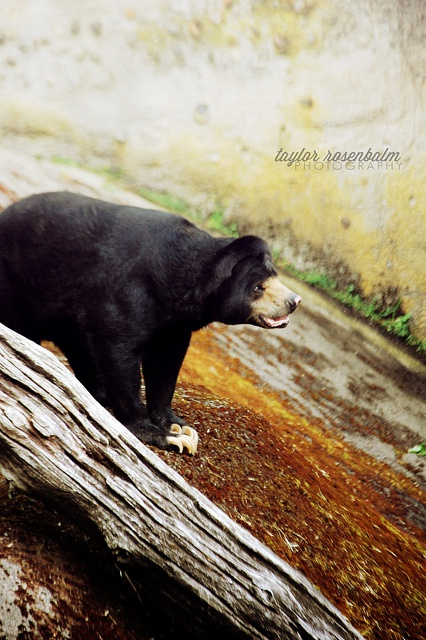Describe the objects in this image and their specific colors. I can see a bear in lightgray, black, gray, and tan tones in this image. 